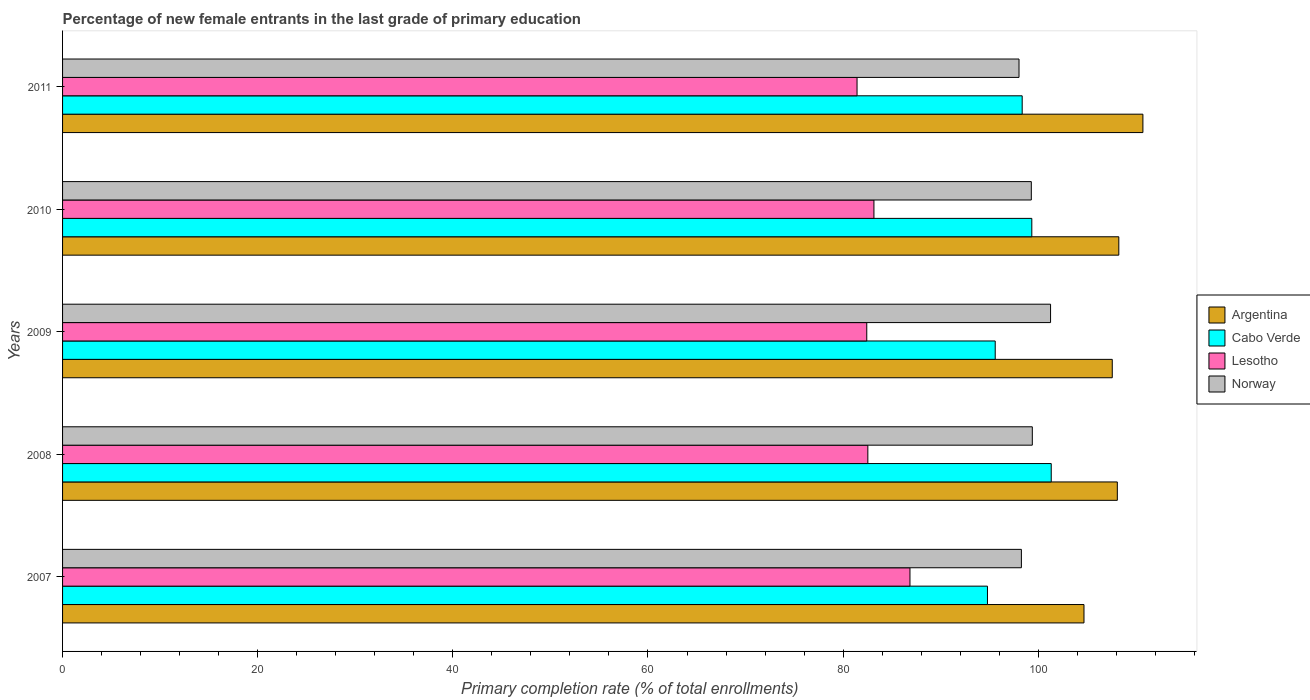How many different coloured bars are there?
Ensure brevity in your answer.  4. Are the number of bars on each tick of the Y-axis equal?
Make the answer very short. Yes. How many bars are there on the 2nd tick from the top?
Offer a very short reply. 4. How many bars are there on the 5th tick from the bottom?
Make the answer very short. 4. What is the label of the 4th group of bars from the top?
Provide a succinct answer. 2008. What is the percentage of new female entrants in Cabo Verde in 2011?
Your response must be concise. 98.35. Across all years, what is the maximum percentage of new female entrants in Cabo Verde?
Keep it short and to the point. 101.33. Across all years, what is the minimum percentage of new female entrants in Argentina?
Keep it short and to the point. 104.69. What is the total percentage of new female entrants in Lesotho in the graph?
Your answer should be very brief. 416.4. What is the difference between the percentage of new female entrants in Argentina in 2009 and that in 2010?
Offer a terse response. -0.67. What is the difference between the percentage of new female entrants in Norway in 2009 and the percentage of new female entrants in Cabo Verde in 2008?
Provide a succinct answer. -0.07. What is the average percentage of new female entrants in Norway per year?
Give a very brief answer. 99.25. In the year 2008, what is the difference between the percentage of new female entrants in Norway and percentage of new female entrants in Cabo Verde?
Your answer should be very brief. -1.94. What is the ratio of the percentage of new female entrants in Argentina in 2007 to that in 2008?
Give a very brief answer. 0.97. What is the difference between the highest and the second highest percentage of new female entrants in Cabo Verde?
Offer a very short reply. 1.99. What is the difference between the highest and the lowest percentage of new female entrants in Lesotho?
Keep it short and to the point. 5.43. What does the 1st bar from the bottom in 2008 represents?
Offer a terse response. Argentina. Is it the case that in every year, the sum of the percentage of new female entrants in Cabo Verde and percentage of new female entrants in Argentina is greater than the percentage of new female entrants in Lesotho?
Keep it short and to the point. Yes. How many bars are there?
Keep it short and to the point. 20. Are all the bars in the graph horizontal?
Offer a very short reply. Yes. What is the difference between two consecutive major ticks on the X-axis?
Keep it short and to the point. 20. Does the graph contain any zero values?
Your answer should be compact. No. What is the title of the graph?
Make the answer very short. Percentage of new female entrants in the last grade of primary education. What is the label or title of the X-axis?
Give a very brief answer. Primary completion rate (% of total enrollments). What is the Primary completion rate (% of total enrollments) in Argentina in 2007?
Your response must be concise. 104.69. What is the Primary completion rate (% of total enrollments) in Cabo Verde in 2007?
Provide a short and direct response. 94.8. What is the Primary completion rate (% of total enrollments) of Lesotho in 2007?
Offer a very short reply. 86.85. What is the Primary completion rate (% of total enrollments) in Norway in 2007?
Provide a succinct answer. 98.27. What is the Primary completion rate (% of total enrollments) in Argentina in 2008?
Your answer should be very brief. 108.11. What is the Primary completion rate (% of total enrollments) in Cabo Verde in 2008?
Make the answer very short. 101.33. What is the Primary completion rate (% of total enrollments) of Lesotho in 2008?
Your response must be concise. 82.54. What is the Primary completion rate (% of total enrollments) in Norway in 2008?
Make the answer very short. 99.39. What is the Primary completion rate (% of total enrollments) of Argentina in 2009?
Offer a very short reply. 107.59. What is the Primary completion rate (% of total enrollments) of Cabo Verde in 2009?
Ensure brevity in your answer.  95.59. What is the Primary completion rate (% of total enrollments) of Lesotho in 2009?
Offer a very short reply. 82.43. What is the Primary completion rate (% of total enrollments) in Norway in 2009?
Your answer should be compact. 101.26. What is the Primary completion rate (% of total enrollments) of Argentina in 2010?
Ensure brevity in your answer.  108.26. What is the Primary completion rate (% of total enrollments) of Cabo Verde in 2010?
Your answer should be compact. 99.34. What is the Primary completion rate (% of total enrollments) in Lesotho in 2010?
Give a very brief answer. 83.16. What is the Primary completion rate (% of total enrollments) of Norway in 2010?
Your answer should be very brief. 99.29. What is the Primary completion rate (% of total enrollments) of Argentina in 2011?
Your response must be concise. 110.73. What is the Primary completion rate (% of total enrollments) of Cabo Verde in 2011?
Keep it short and to the point. 98.35. What is the Primary completion rate (% of total enrollments) of Lesotho in 2011?
Your answer should be very brief. 81.43. What is the Primary completion rate (% of total enrollments) of Norway in 2011?
Keep it short and to the point. 98.03. Across all years, what is the maximum Primary completion rate (% of total enrollments) in Argentina?
Your answer should be compact. 110.73. Across all years, what is the maximum Primary completion rate (% of total enrollments) of Cabo Verde?
Your answer should be very brief. 101.33. Across all years, what is the maximum Primary completion rate (% of total enrollments) of Lesotho?
Provide a short and direct response. 86.85. Across all years, what is the maximum Primary completion rate (% of total enrollments) in Norway?
Ensure brevity in your answer.  101.26. Across all years, what is the minimum Primary completion rate (% of total enrollments) in Argentina?
Keep it short and to the point. 104.69. Across all years, what is the minimum Primary completion rate (% of total enrollments) in Cabo Verde?
Provide a succinct answer. 94.8. Across all years, what is the minimum Primary completion rate (% of total enrollments) of Lesotho?
Provide a short and direct response. 81.43. Across all years, what is the minimum Primary completion rate (% of total enrollments) in Norway?
Keep it short and to the point. 98.03. What is the total Primary completion rate (% of total enrollments) in Argentina in the graph?
Make the answer very short. 539.37. What is the total Primary completion rate (% of total enrollments) of Cabo Verde in the graph?
Your answer should be compact. 489.41. What is the total Primary completion rate (% of total enrollments) in Lesotho in the graph?
Ensure brevity in your answer.  416.4. What is the total Primary completion rate (% of total enrollments) of Norway in the graph?
Provide a succinct answer. 496.25. What is the difference between the Primary completion rate (% of total enrollments) of Argentina in 2007 and that in 2008?
Offer a terse response. -3.42. What is the difference between the Primary completion rate (% of total enrollments) in Cabo Verde in 2007 and that in 2008?
Offer a terse response. -6.54. What is the difference between the Primary completion rate (% of total enrollments) in Lesotho in 2007 and that in 2008?
Provide a short and direct response. 4.32. What is the difference between the Primary completion rate (% of total enrollments) in Norway in 2007 and that in 2008?
Provide a short and direct response. -1.12. What is the difference between the Primary completion rate (% of total enrollments) of Argentina in 2007 and that in 2009?
Give a very brief answer. -2.9. What is the difference between the Primary completion rate (% of total enrollments) in Cabo Verde in 2007 and that in 2009?
Provide a short and direct response. -0.8. What is the difference between the Primary completion rate (% of total enrollments) in Lesotho in 2007 and that in 2009?
Provide a short and direct response. 4.43. What is the difference between the Primary completion rate (% of total enrollments) in Norway in 2007 and that in 2009?
Your answer should be compact. -2.99. What is the difference between the Primary completion rate (% of total enrollments) in Argentina in 2007 and that in 2010?
Provide a short and direct response. -3.57. What is the difference between the Primary completion rate (% of total enrollments) in Cabo Verde in 2007 and that in 2010?
Your answer should be compact. -4.55. What is the difference between the Primary completion rate (% of total enrollments) of Lesotho in 2007 and that in 2010?
Provide a succinct answer. 3.69. What is the difference between the Primary completion rate (% of total enrollments) in Norway in 2007 and that in 2010?
Make the answer very short. -1.02. What is the difference between the Primary completion rate (% of total enrollments) of Argentina in 2007 and that in 2011?
Offer a terse response. -6.04. What is the difference between the Primary completion rate (% of total enrollments) in Cabo Verde in 2007 and that in 2011?
Your answer should be compact. -3.56. What is the difference between the Primary completion rate (% of total enrollments) in Lesotho in 2007 and that in 2011?
Give a very brief answer. 5.42. What is the difference between the Primary completion rate (% of total enrollments) of Norway in 2007 and that in 2011?
Ensure brevity in your answer.  0.24. What is the difference between the Primary completion rate (% of total enrollments) of Argentina in 2008 and that in 2009?
Your answer should be very brief. 0.52. What is the difference between the Primary completion rate (% of total enrollments) of Cabo Verde in 2008 and that in 2009?
Offer a terse response. 5.74. What is the difference between the Primary completion rate (% of total enrollments) in Lesotho in 2008 and that in 2009?
Ensure brevity in your answer.  0.11. What is the difference between the Primary completion rate (% of total enrollments) in Norway in 2008 and that in 2009?
Make the answer very short. -1.87. What is the difference between the Primary completion rate (% of total enrollments) in Argentina in 2008 and that in 2010?
Offer a terse response. -0.15. What is the difference between the Primary completion rate (% of total enrollments) in Cabo Verde in 2008 and that in 2010?
Provide a short and direct response. 1.99. What is the difference between the Primary completion rate (% of total enrollments) in Lesotho in 2008 and that in 2010?
Provide a short and direct response. -0.62. What is the difference between the Primary completion rate (% of total enrollments) in Norway in 2008 and that in 2010?
Offer a terse response. 0.1. What is the difference between the Primary completion rate (% of total enrollments) of Argentina in 2008 and that in 2011?
Offer a very short reply. -2.62. What is the difference between the Primary completion rate (% of total enrollments) in Cabo Verde in 2008 and that in 2011?
Offer a terse response. 2.98. What is the difference between the Primary completion rate (% of total enrollments) in Lesotho in 2008 and that in 2011?
Provide a succinct answer. 1.11. What is the difference between the Primary completion rate (% of total enrollments) in Norway in 2008 and that in 2011?
Your answer should be compact. 1.36. What is the difference between the Primary completion rate (% of total enrollments) in Argentina in 2009 and that in 2010?
Make the answer very short. -0.67. What is the difference between the Primary completion rate (% of total enrollments) of Cabo Verde in 2009 and that in 2010?
Provide a succinct answer. -3.75. What is the difference between the Primary completion rate (% of total enrollments) of Lesotho in 2009 and that in 2010?
Make the answer very short. -0.73. What is the difference between the Primary completion rate (% of total enrollments) in Norway in 2009 and that in 2010?
Keep it short and to the point. 1.97. What is the difference between the Primary completion rate (% of total enrollments) of Argentina in 2009 and that in 2011?
Your answer should be compact. -3.14. What is the difference between the Primary completion rate (% of total enrollments) of Cabo Verde in 2009 and that in 2011?
Provide a succinct answer. -2.76. What is the difference between the Primary completion rate (% of total enrollments) in Lesotho in 2009 and that in 2011?
Give a very brief answer. 1. What is the difference between the Primary completion rate (% of total enrollments) of Norway in 2009 and that in 2011?
Ensure brevity in your answer.  3.23. What is the difference between the Primary completion rate (% of total enrollments) in Argentina in 2010 and that in 2011?
Your response must be concise. -2.47. What is the difference between the Primary completion rate (% of total enrollments) of Lesotho in 2010 and that in 2011?
Provide a succinct answer. 1.73. What is the difference between the Primary completion rate (% of total enrollments) of Norway in 2010 and that in 2011?
Give a very brief answer. 1.26. What is the difference between the Primary completion rate (% of total enrollments) in Argentina in 2007 and the Primary completion rate (% of total enrollments) in Cabo Verde in 2008?
Provide a short and direct response. 3.36. What is the difference between the Primary completion rate (% of total enrollments) in Argentina in 2007 and the Primary completion rate (% of total enrollments) in Lesotho in 2008?
Provide a succinct answer. 22.15. What is the difference between the Primary completion rate (% of total enrollments) of Argentina in 2007 and the Primary completion rate (% of total enrollments) of Norway in 2008?
Make the answer very short. 5.3. What is the difference between the Primary completion rate (% of total enrollments) in Cabo Verde in 2007 and the Primary completion rate (% of total enrollments) in Lesotho in 2008?
Your response must be concise. 12.26. What is the difference between the Primary completion rate (% of total enrollments) of Cabo Verde in 2007 and the Primary completion rate (% of total enrollments) of Norway in 2008?
Provide a short and direct response. -4.6. What is the difference between the Primary completion rate (% of total enrollments) in Lesotho in 2007 and the Primary completion rate (% of total enrollments) in Norway in 2008?
Offer a very short reply. -12.54. What is the difference between the Primary completion rate (% of total enrollments) in Argentina in 2007 and the Primary completion rate (% of total enrollments) in Cabo Verde in 2009?
Your response must be concise. 9.1. What is the difference between the Primary completion rate (% of total enrollments) of Argentina in 2007 and the Primary completion rate (% of total enrollments) of Lesotho in 2009?
Keep it short and to the point. 22.26. What is the difference between the Primary completion rate (% of total enrollments) of Argentina in 2007 and the Primary completion rate (% of total enrollments) of Norway in 2009?
Keep it short and to the point. 3.43. What is the difference between the Primary completion rate (% of total enrollments) in Cabo Verde in 2007 and the Primary completion rate (% of total enrollments) in Lesotho in 2009?
Provide a short and direct response. 12.37. What is the difference between the Primary completion rate (% of total enrollments) in Cabo Verde in 2007 and the Primary completion rate (% of total enrollments) in Norway in 2009?
Give a very brief answer. -6.47. What is the difference between the Primary completion rate (% of total enrollments) of Lesotho in 2007 and the Primary completion rate (% of total enrollments) of Norway in 2009?
Ensure brevity in your answer.  -14.41. What is the difference between the Primary completion rate (% of total enrollments) of Argentina in 2007 and the Primary completion rate (% of total enrollments) of Cabo Verde in 2010?
Provide a short and direct response. 5.35. What is the difference between the Primary completion rate (% of total enrollments) of Argentina in 2007 and the Primary completion rate (% of total enrollments) of Lesotho in 2010?
Provide a succinct answer. 21.53. What is the difference between the Primary completion rate (% of total enrollments) of Argentina in 2007 and the Primary completion rate (% of total enrollments) of Norway in 2010?
Give a very brief answer. 5.4. What is the difference between the Primary completion rate (% of total enrollments) of Cabo Verde in 2007 and the Primary completion rate (% of total enrollments) of Lesotho in 2010?
Give a very brief answer. 11.64. What is the difference between the Primary completion rate (% of total enrollments) of Cabo Verde in 2007 and the Primary completion rate (% of total enrollments) of Norway in 2010?
Give a very brief answer. -4.49. What is the difference between the Primary completion rate (% of total enrollments) of Lesotho in 2007 and the Primary completion rate (% of total enrollments) of Norway in 2010?
Provide a succinct answer. -12.44. What is the difference between the Primary completion rate (% of total enrollments) in Argentina in 2007 and the Primary completion rate (% of total enrollments) in Cabo Verde in 2011?
Provide a succinct answer. 6.34. What is the difference between the Primary completion rate (% of total enrollments) in Argentina in 2007 and the Primary completion rate (% of total enrollments) in Lesotho in 2011?
Offer a terse response. 23.26. What is the difference between the Primary completion rate (% of total enrollments) in Argentina in 2007 and the Primary completion rate (% of total enrollments) in Norway in 2011?
Offer a terse response. 6.66. What is the difference between the Primary completion rate (% of total enrollments) in Cabo Verde in 2007 and the Primary completion rate (% of total enrollments) in Lesotho in 2011?
Provide a short and direct response. 13.37. What is the difference between the Primary completion rate (% of total enrollments) in Cabo Verde in 2007 and the Primary completion rate (% of total enrollments) in Norway in 2011?
Ensure brevity in your answer.  -3.23. What is the difference between the Primary completion rate (% of total enrollments) of Lesotho in 2007 and the Primary completion rate (% of total enrollments) of Norway in 2011?
Keep it short and to the point. -11.18. What is the difference between the Primary completion rate (% of total enrollments) in Argentina in 2008 and the Primary completion rate (% of total enrollments) in Cabo Verde in 2009?
Your answer should be compact. 12.51. What is the difference between the Primary completion rate (% of total enrollments) in Argentina in 2008 and the Primary completion rate (% of total enrollments) in Lesotho in 2009?
Make the answer very short. 25.68. What is the difference between the Primary completion rate (% of total enrollments) of Argentina in 2008 and the Primary completion rate (% of total enrollments) of Norway in 2009?
Keep it short and to the point. 6.84. What is the difference between the Primary completion rate (% of total enrollments) of Cabo Verde in 2008 and the Primary completion rate (% of total enrollments) of Lesotho in 2009?
Make the answer very short. 18.91. What is the difference between the Primary completion rate (% of total enrollments) of Cabo Verde in 2008 and the Primary completion rate (% of total enrollments) of Norway in 2009?
Provide a succinct answer. 0.07. What is the difference between the Primary completion rate (% of total enrollments) of Lesotho in 2008 and the Primary completion rate (% of total enrollments) of Norway in 2009?
Offer a very short reply. -18.73. What is the difference between the Primary completion rate (% of total enrollments) of Argentina in 2008 and the Primary completion rate (% of total enrollments) of Cabo Verde in 2010?
Make the answer very short. 8.76. What is the difference between the Primary completion rate (% of total enrollments) of Argentina in 2008 and the Primary completion rate (% of total enrollments) of Lesotho in 2010?
Your response must be concise. 24.95. What is the difference between the Primary completion rate (% of total enrollments) of Argentina in 2008 and the Primary completion rate (% of total enrollments) of Norway in 2010?
Provide a succinct answer. 8.82. What is the difference between the Primary completion rate (% of total enrollments) in Cabo Verde in 2008 and the Primary completion rate (% of total enrollments) in Lesotho in 2010?
Offer a terse response. 18.17. What is the difference between the Primary completion rate (% of total enrollments) of Cabo Verde in 2008 and the Primary completion rate (% of total enrollments) of Norway in 2010?
Your answer should be very brief. 2.04. What is the difference between the Primary completion rate (% of total enrollments) in Lesotho in 2008 and the Primary completion rate (% of total enrollments) in Norway in 2010?
Your answer should be compact. -16.75. What is the difference between the Primary completion rate (% of total enrollments) of Argentina in 2008 and the Primary completion rate (% of total enrollments) of Cabo Verde in 2011?
Offer a terse response. 9.75. What is the difference between the Primary completion rate (% of total enrollments) of Argentina in 2008 and the Primary completion rate (% of total enrollments) of Lesotho in 2011?
Provide a short and direct response. 26.68. What is the difference between the Primary completion rate (% of total enrollments) in Argentina in 2008 and the Primary completion rate (% of total enrollments) in Norway in 2011?
Your answer should be very brief. 10.08. What is the difference between the Primary completion rate (% of total enrollments) of Cabo Verde in 2008 and the Primary completion rate (% of total enrollments) of Lesotho in 2011?
Give a very brief answer. 19.9. What is the difference between the Primary completion rate (% of total enrollments) of Cabo Verde in 2008 and the Primary completion rate (% of total enrollments) of Norway in 2011?
Your answer should be compact. 3.3. What is the difference between the Primary completion rate (% of total enrollments) of Lesotho in 2008 and the Primary completion rate (% of total enrollments) of Norway in 2011?
Offer a very short reply. -15.49. What is the difference between the Primary completion rate (% of total enrollments) in Argentina in 2009 and the Primary completion rate (% of total enrollments) in Cabo Verde in 2010?
Offer a very short reply. 8.25. What is the difference between the Primary completion rate (% of total enrollments) of Argentina in 2009 and the Primary completion rate (% of total enrollments) of Lesotho in 2010?
Your answer should be compact. 24.43. What is the difference between the Primary completion rate (% of total enrollments) in Argentina in 2009 and the Primary completion rate (% of total enrollments) in Norway in 2010?
Your response must be concise. 8.3. What is the difference between the Primary completion rate (% of total enrollments) in Cabo Verde in 2009 and the Primary completion rate (% of total enrollments) in Lesotho in 2010?
Ensure brevity in your answer.  12.43. What is the difference between the Primary completion rate (% of total enrollments) of Cabo Verde in 2009 and the Primary completion rate (% of total enrollments) of Norway in 2010?
Offer a terse response. -3.7. What is the difference between the Primary completion rate (% of total enrollments) of Lesotho in 2009 and the Primary completion rate (% of total enrollments) of Norway in 2010?
Give a very brief answer. -16.86. What is the difference between the Primary completion rate (% of total enrollments) of Argentina in 2009 and the Primary completion rate (% of total enrollments) of Cabo Verde in 2011?
Your response must be concise. 9.23. What is the difference between the Primary completion rate (% of total enrollments) of Argentina in 2009 and the Primary completion rate (% of total enrollments) of Lesotho in 2011?
Give a very brief answer. 26.16. What is the difference between the Primary completion rate (% of total enrollments) in Argentina in 2009 and the Primary completion rate (% of total enrollments) in Norway in 2011?
Provide a short and direct response. 9.56. What is the difference between the Primary completion rate (% of total enrollments) in Cabo Verde in 2009 and the Primary completion rate (% of total enrollments) in Lesotho in 2011?
Ensure brevity in your answer.  14.16. What is the difference between the Primary completion rate (% of total enrollments) of Cabo Verde in 2009 and the Primary completion rate (% of total enrollments) of Norway in 2011?
Provide a succinct answer. -2.44. What is the difference between the Primary completion rate (% of total enrollments) of Lesotho in 2009 and the Primary completion rate (% of total enrollments) of Norway in 2011?
Your answer should be very brief. -15.6. What is the difference between the Primary completion rate (% of total enrollments) of Argentina in 2010 and the Primary completion rate (% of total enrollments) of Cabo Verde in 2011?
Your answer should be very brief. 9.9. What is the difference between the Primary completion rate (% of total enrollments) of Argentina in 2010 and the Primary completion rate (% of total enrollments) of Lesotho in 2011?
Your answer should be very brief. 26.83. What is the difference between the Primary completion rate (% of total enrollments) in Argentina in 2010 and the Primary completion rate (% of total enrollments) in Norway in 2011?
Your response must be concise. 10.23. What is the difference between the Primary completion rate (% of total enrollments) in Cabo Verde in 2010 and the Primary completion rate (% of total enrollments) in Lesotho in 2011?
Make the answer very short. 17.91. What is the difference between the Primary completion rate (% of total enrollments) in Cabo Verde in 2010 and the Primary completion rate (% of total enrollments) in Norway in 2011?
Ensure brevity in your answer.  1.31. What is the difference between the Primary completion rate (% of total enrollments) in Lesotho in 2010 and the Primary completion rate (% of total enrollments) in Norway in 2011?
Provide a short and direct response. -14.87. What is the average Primary completion rate (% of total enrollments) of Argentina per year?
Offer a terse response. 107.87. What is the average Primary completion rate (% of total enrollments) of Cabo Verde per year?
Your response must be concise. 97.88. What is the average Primary completion rate (% of total enrollments) of Lesotho per year?
Keep it short and to the point. 83.28. What is the average Primary completion rate (% of total enrollments) in Norway per year?
Provide a short and direct response. 99.25. In the year 2007, what is the difference between the Primary completion rate (% of total enrollments) of Argentina and Primary completion rate (% of total enrollments) of Cabo Verde?
Make the answer very short. 9.89. In the year 2007, what is the difference between the Primary completion rate (% of total enrollments) in Argentina and Primary completion rate (% of total enrollments) in Lesotho?
Offer a terse response. 17.84. In the year 2007, what is the difference between the Primary completion rate (% of total enrollments) in Argentina and Primary completion rate (% of total enrollments) in Norway?
Provide a succinct answer. 6.42. In the year 2007, what is the difference between the Primary completion rate (% of total enrollments) in Cabo Verde and Primary completion rate (% of total enrollments) in Lesotho?
Give a very brief answer. 7.94. In the year 2007, what is the difference between the Primary completion rate (% of total enrollments) of Cabo Verde and Primary completion rate (% of total enrollments) of Norway?
Your answer should be compact. -3.48. In the year 2007, what is the difference between the Primary completion rate (% of total enrollments) of Lesotho and Primary completion rate (% of total enrollments) of Norway?
Keep it short and to the point. -11.42. In the year 2008, what is the difference between the Primary completion rate (% of total enrollments) of Argentina and Primary completion rate (% of total enrollments) of Cabo Verde?
Your answer should be compact. 6.77. In the year 2008, what is the difference between the Primary completion rate (% of total enrollments) in Argentina and Primary completion rate (% of total enrollments) in Lesotho?
Ensure brevity in your answer.  25.57. In the year 2008, what is the difference between the Primary completion rate (% of total enrollments) of Argentina and Primary completion rate (% of total enrollments) of Norway?
Your answer should be very brief. 8.71. In the year 2008, what is the difference between the Primary completion rate (% of total enrollments) of Cabo Verde and Primary completion rate (% of total enrollments) of Lesotho?
Offer a very short reply. 18.8. In the year 2008, what is the difference between the Primary completion rate (% of total enrollments) of Cabo Verde and Primary completion rate (% of total enrollments) of Norway?
Provide a succinct answer. 1.94. In the year 2008, what is the difference between the Primary completion rate (% of total enrollments) in Lesotho and Primary completion rate (% of total enrollments) in Norway?
Ensure brevity in your answer.  -16.86. In the year 2009, what is the difference between the Primary completion rate (% of total enrollments) in Argentina and Primary completion rate (% of total enrollments) in Cabo Verde?
Provide a short and direct response. 12. In the year 2009, what is the difference between the Primary completion rate (% of total enrollments) of Argentina and Primary completion rate (% of total enrollments) of Lesotho?
Give a very brief answer. 25.16. In the year 2009, what is the difference between the Primary completion rate (% of total enrollments) of Argentina and Primary completion rate (% of total enrollments) of Norway?
Your answer should be very brief. 6.32. In the year 2009, what is the difference between the Primary completion rate (% of total enrollments) of Cabo Verde and Primary completion rate (% of total enrollments) of Lesotho?
Offer a terse response. 13.17. In the year 2009, what is the difference between the Primary completion rate (% of total enrollments) of Cabo Verde and Primary completion rate (% of total enrollments) of Norway?
Keep it short and to the point. -5.67. In the year 2009, what is the difference between the Primary completion rate (% of total enrollments) of Lesotho and Primary completion rate (% of total enrollments) of Norway?
Provide a short and direct response. -18.84. In the year 2010, what is the difference between the Primary completion rate (% of total enrollments) in Argentina and Primary completion rate (% of total enrollments) in Cabo Verde?
Make the answer very short. 8.92. In the year 2010, what is the difference between the Primary completion rate (% of total enrollments) of Argentina and Primary completion rate (% of total enrollments) of Lesotho?
Keep it short and to the point. 25.1. In the year 2010, what is the difference between the Primary completion rate (% of total enrollments) of Argentina and Primary completion rate (% of total enrollments) of Norway?
Provide a succinct answer. 8.97. In the year 2010, what is the difference between the Primary completion rate (% of total enrollments) of Cabo Verde and Primary completion rate (% of total enrollments) of Lesotho?
Give a very brief answer. 16.18. In the year 2010, what is the difference between the Primary completion rate (% of total enrollments) of Cabo Verde and Primary completion rate (% of total enrollments) of Norway?
Ensure brevity in your answer.  0.05. In the year 2010, what is the difference between the Primary completion rate (% of total enrollments) in Lesotho and Primary completion rate (% of total enrollments) in Norway?
Provide a succinct answer. -16.13. In the year 2011, what is the difference between the Primary completion rate (% of total enrollments) in Argentina and Primary completion rate (% of total enrollments) in Cabo Verde?
Offer a terse response. 12.37. In the year 2011, what is the difference between the Primary completion rate (% of total enrollments) in Argentina and Primary completion rate (% of total enrollments) in Lesotho?
Make the answer very short. 29.3. In the year 2011, what is the difference between the Primary completion rate (% of total enrollments) in Argentina and Primary completion rate (% of total enrollments) in Norway?
Provide a short and direct response. 12.7. In the year 2011, what is the difference between the Primary completion rate (% of total enrollments) in Cabo Verde and Primary completion rate (% of total enrollments) in Lesotho?
Your response must be concise. 16.93. In the year 2011, what is the difference between the Primary completion rate (% of total enrollments) in Cabo Verde and Primary completion rate (% of total enrollments) in Norway?
Provide a succinct answer. 0.32. In the year 2011, what is the difference between the Primary completion rate (% of total enrollments) of Lesotho and Primary completion rate (% of total enrollments) of Norway?
Your response must be concise. -16.6. What is the ratio of the Primary completion rate (% of total enrollments) in Argentina in 2007 to that in 2008?
Offer a very short reply. 0.97. What is the ratio of the Primary completion rate (% of total enrollments) in Cabo Verde in 2007 to that in 2008?
Your answer should be very brief. 0.94. What is the ratio of the Primary completion rate (% of total enrollments) of Lesotho in 2007 to that in 2008?
Make the answer very short. 1.05. What is the ratio of the Primary completion rate (% of total enrollments) in Norway in 2007 to that in 2008?
Provide a succinct answer. 0.99. What is the ratio of the Primary completion rate (% of total enrollments) of Argentina in 2007 to that in 2009?
Keep it short and to the point. 0.97. What is the ratio of the Primary completion rate (% of total enrollments) in Cabo Verde in 2007 to that in 2009?
Provide a short and direct response. 0.99. What is the ratio of the Primary completion rate (% of total enrollments) of Lesotho in 2007 to that in 2009?
Ensure brevity in your answer.  1.05. What is the ratio of the Primary completion rate (% of total enrollments) in Norway in 2007 to that in 2009?
Your answer should be very brief. 0.97. What is the ratio of the Primary completion rate (% of total enrollments) of Argentina in 2007 to that in 2010?
Provide a succinct answer. 0.97. What is the ratio of the Primary completion rate (% of total enrollments) in Cabo Verde in 2007 to that in 2010?
Your answer should be very brief. 0.95. What is the ratio of the Primary completion rate (% of total enrollments) in Lesotho in 2007 to that in 2010?
Your answer should be very brief. 1.04. What is the ratio of the Primary completion rate (% of total enrollments) of Argentina in 2007 to that in 2011?
Your response must be concise. 0.95. What is the ratio of the Primary completion rate (% of total enrollments) of Cabo Verde in 2007 to that in 2011?
Your response must be concise. 0.96. What is the ratio of the Primary completion rate (% of total enrollments) in Lesotho in 2007 to that in 2011?
Provide a short and direct response. 1.07. What is the ratio of the Primary completion rate (% of total enrollments) of Cabo Verde in 2008 to that in 2009?
Give a very brief answer. 1.06. What is the ratio of the Primary completion rate (% of total enrollments) of Lesotho in 2008 to that in 2009?
Ensure brevity in your answer.  1. What is the ratio of the Primary completion rate (% of total enrollments) in Norway in 2008 to that in 2009?
Make the answer very short. 0.98. What is the ratio of the Primary completion rate (% of total enrollments) in Cabo Verde in 2008 to that in 2010?
Provide a succinct answer. 1.02. What is the ratio of the Primary completion rate (% of total enrollments) of Lesotho in 2008 to that in 2010?
Give a very brief answer. 0.99. What is the ratio of the Primary completion rate (% of total enrollments) in Norway in 2008 to that in 2010?
Keep it short and to the point. 1. What is the ratio of the Primary completion rate (% of total enrollments) in Argentina in 2008 to that in 2011?
Your response must be concise. 0.98. What is the ratio of the Primary completion rate (% of total enrollments) of Cabo Verde in 2008 to that in 2011?
Your response must be concise. 1.03. What is the ratio of the Primary completion rate (% of total enrollments) in Lesotho in 2008 to that in 2011?
Provide a succinct answer. 1.01. What is the ratio of the Primary completion rate (% of total enrollments) in Norway in 2008 to that in 2011?
Your response must be concise. 1.01. What is the ratio of the Primary completion rate (% of total enrollments) of Argentina in 2009 to that in 2010?
Give a very brief answer. 0.99. What is the ratio of the Primary completion rate (% of total enrollments) in Cabo Verde in 2009 to that in 2010?
Offer a very short reply. 0.96. What is the ratio of the Primary completion rate (% of total enrollments) in Lesotho in 2009 to that in 2010?
Your answer should be very brief. 0.99. What is the ratio of the Primary completion rate (% of total enrollments) of Norway in 2009 to that in 2010?
Provide a succinct answer. 1.02. What is the ratio of the Primary completion rate (% of total enrollments) in Argentina in 2009 to that in 2011?
Provide a succinct answer. 0.97. What is the ratio of the Primary completion rate (% of total enrollments) of Cabo Verde in 2009 to that in 2011?
Provide a succinct answer. 0.97. What is the ratio of the Primary completion rate (% of total enrollments) in Lesotho in 2009 to that in 2011?
Your answer should be very brief. 1.01. What is the ratio of the Primary completion rate (% of total enrollments) of Norway in 2009 to that in 2011?
Make the answer very short. 1.03. What is the ratio of the Primary completion rate (% of total enrollments) in Argentina in 2010 to that in 2011?
Provide a succinct answer. 0.98. What is the ratio of the Primary completion rate (% of total enrollments) in Cabo Verde in 2010 to that in 2011?
Your answer should be compact. 1.01. What is the ratio of the Primary completion rate (% of total enrollments) of Lesotho in 2010 to that in 2011?
Ensure brevity in your answer.  1.02. What is the ratio of the Primary completion rate (% of total enrollments) in Norway in 2010 to that in 2011?
Give a very brief answer. 1.01. What is the difference between the highest and the second highest Primary completion rate (% of total enrollments) in Argentina?
Ensure brevity in your answer.  2.47. What is the difference between the highest and the second highest Primary completion rate (% of total enrollments) of Cabo Verde?
Give a very brief answer. 1.99. What is the difference between the highest and the second highest Primary completion rate (% of total enrollments) of Lesotho?
Provide a succinct answer. 3.69. What is the difference between the highest and the second highest Primary completion rate (% of total enrollments) of Norway?
Provide a succinct answer. 1.87. What is the difference between the highest and the lowest Primary completion rate (% of total enrollments) of Argentina?
Make the answer very short. 6.04. What is the difference between the highest and the lowest Primary completion rate (% of total enrollments) of Cabo Verde?
Your answer should be very brief. 6.54. What is the difference between the highest and the lowest Primary completion rate (% of total enrollments) in Lesotho?
Give a very brief answer. 5.42. What is the difference between the highest and the lowest Primary completion rate (% of total enrollments) in Norway?
Your response must be concise. 3.23. 